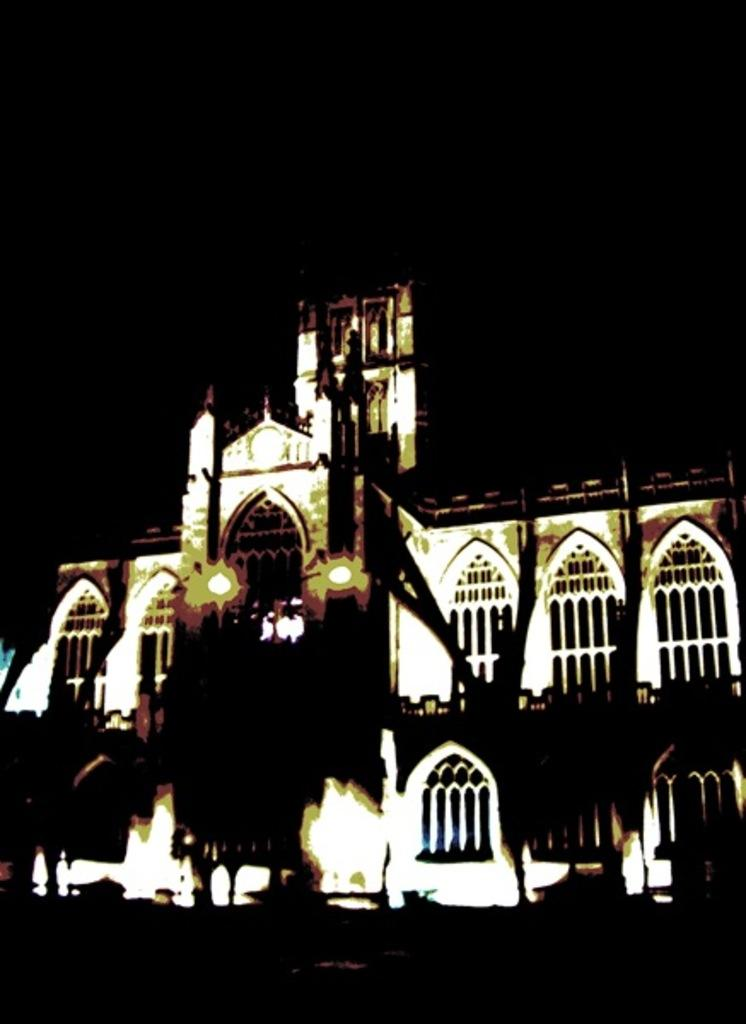What type of structure is visible in the image? There is a building in the image. What feature can be seen on the building? The building has windows. What other objects are present in the image? There are lamp posts in the image. How many visitors can be seen enjoying their vacation at the grain field in the image? There are no visitors or grain fields present in the image; it features a building with windows and lamp posts. 